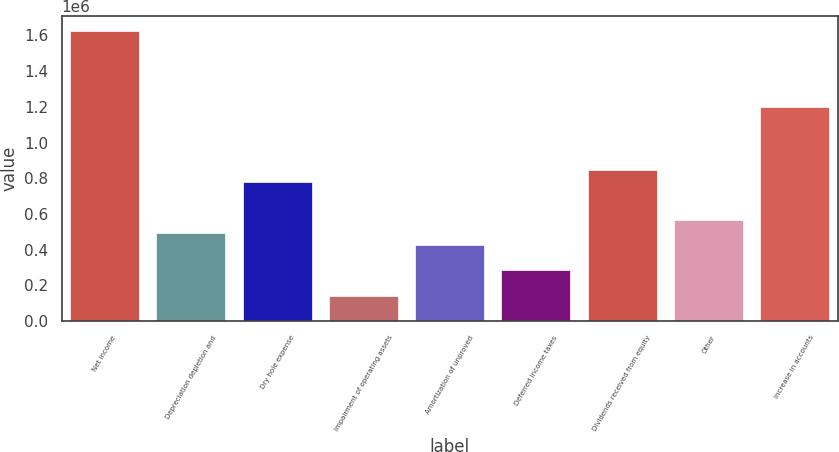<chart> <loc_0><loc_0><loc_500><loc_500><bar_chart><fcel>Net income<fcel>Depreciation depletion and<fcel>Dry hole expense<fcel>Impairment of operating assets<fcel>Amortization of unproved<fcel>Deferred income taxes<fcel>Dividends received from equity<fcel>Other<fcel>Increase in accounts<nl><fcel>1.62536e+06<fcel>496530<fcel>778738<fcel>143769<fcel>425978<fcel>284873<fcel>849290<fcel>567082<fcel>1.20205e+06<nl></chart> 